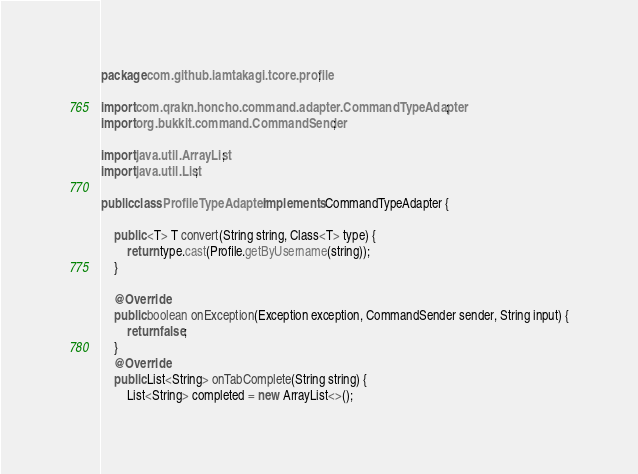<code> <loc_0><loc_0><loc_500><loc_500><_Java_>package com.github.iamtakagi.tcore.profile;

import com.qrakn.honcho.command.adapter.CommandTypeAdapter;
import org.bukkit.command.CommandSender;

import java.util.ArrayList;
import java.util.List;

public class ProfileTypeAdapter implements CommandTypeAdapter {

	public <T> T convert(String string, Class<T> type) {
		return type.cast(Profile.getByUsername(string));
	}

	@Override
	public boolean onException(Exception exception, CommandSender sender, String input) {
		return false;
	}
	@Override
	public List<String> onTabComplete(String string) {
		List<String> completed = new ArrayList<>();
</code> 